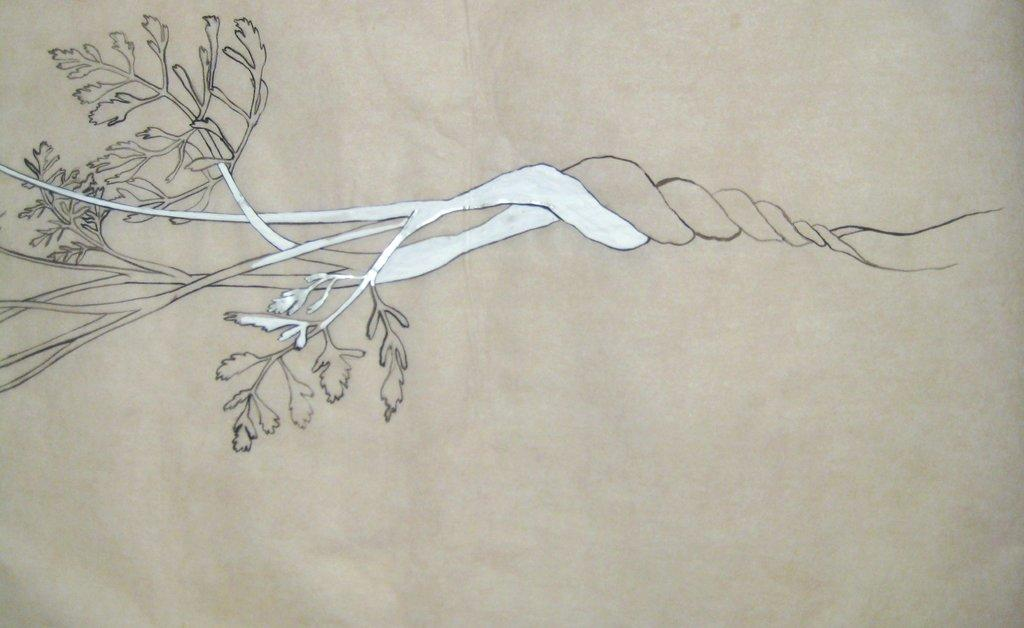What is the main subject of the image? There is a painting in the image. What is depicted in the painting? The painting depicts a tree. How many visitors can be seen interacting with the tree in the painting? There are no visitors present in the painting; it only depicts a tree. What type of lift is used to transport the tree in the painting? There is no lift present in the painting; it only depicts a tree. 